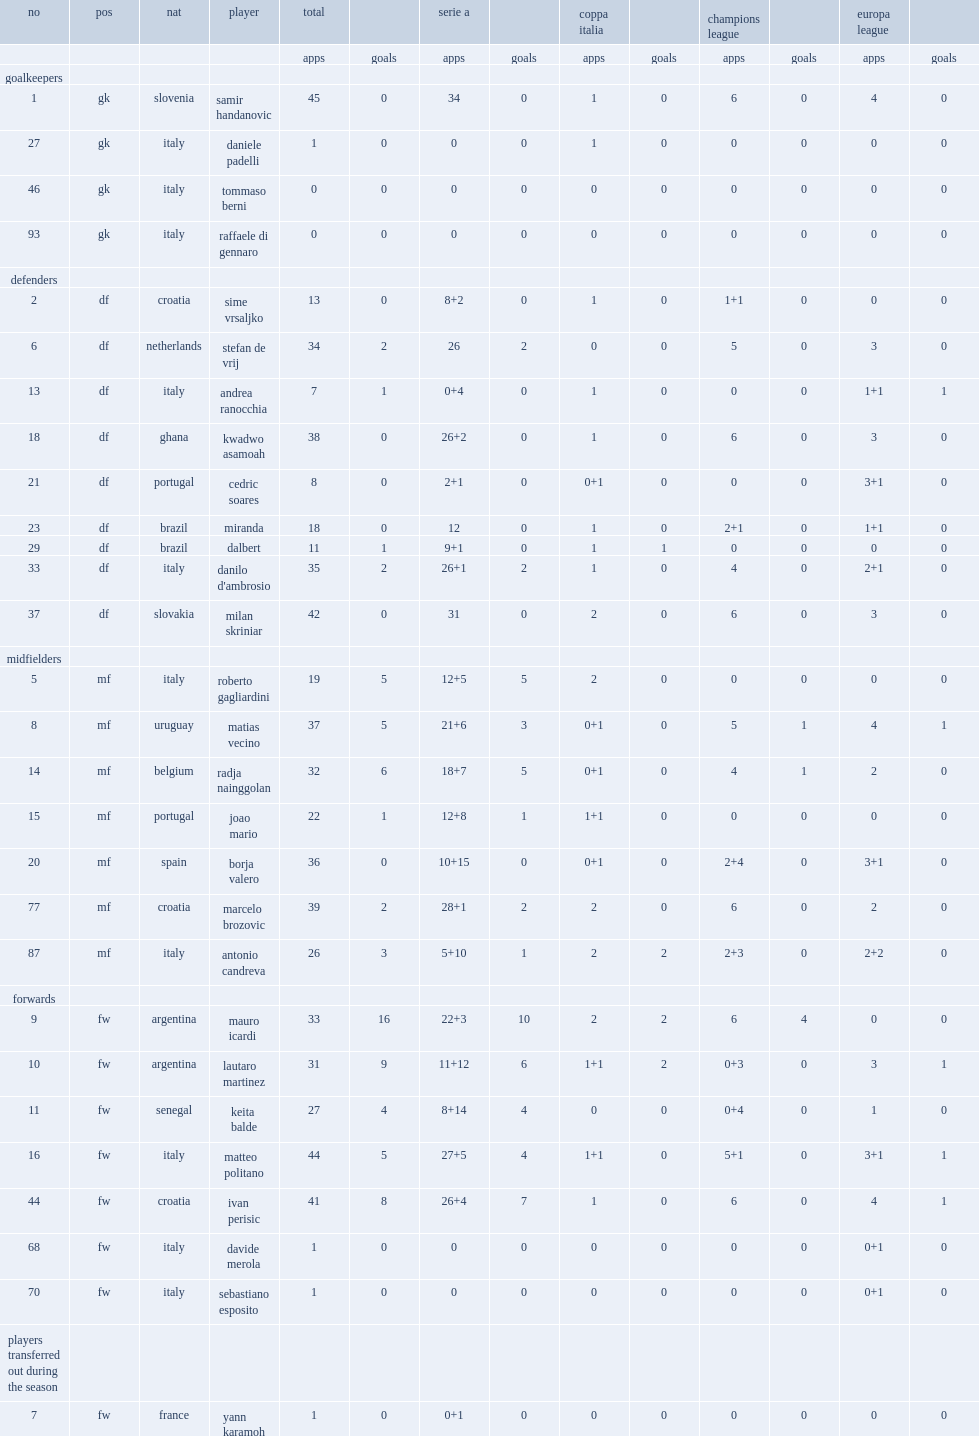What the matches have inter milan competed in? Serie a coppa italia champions league europa league. 